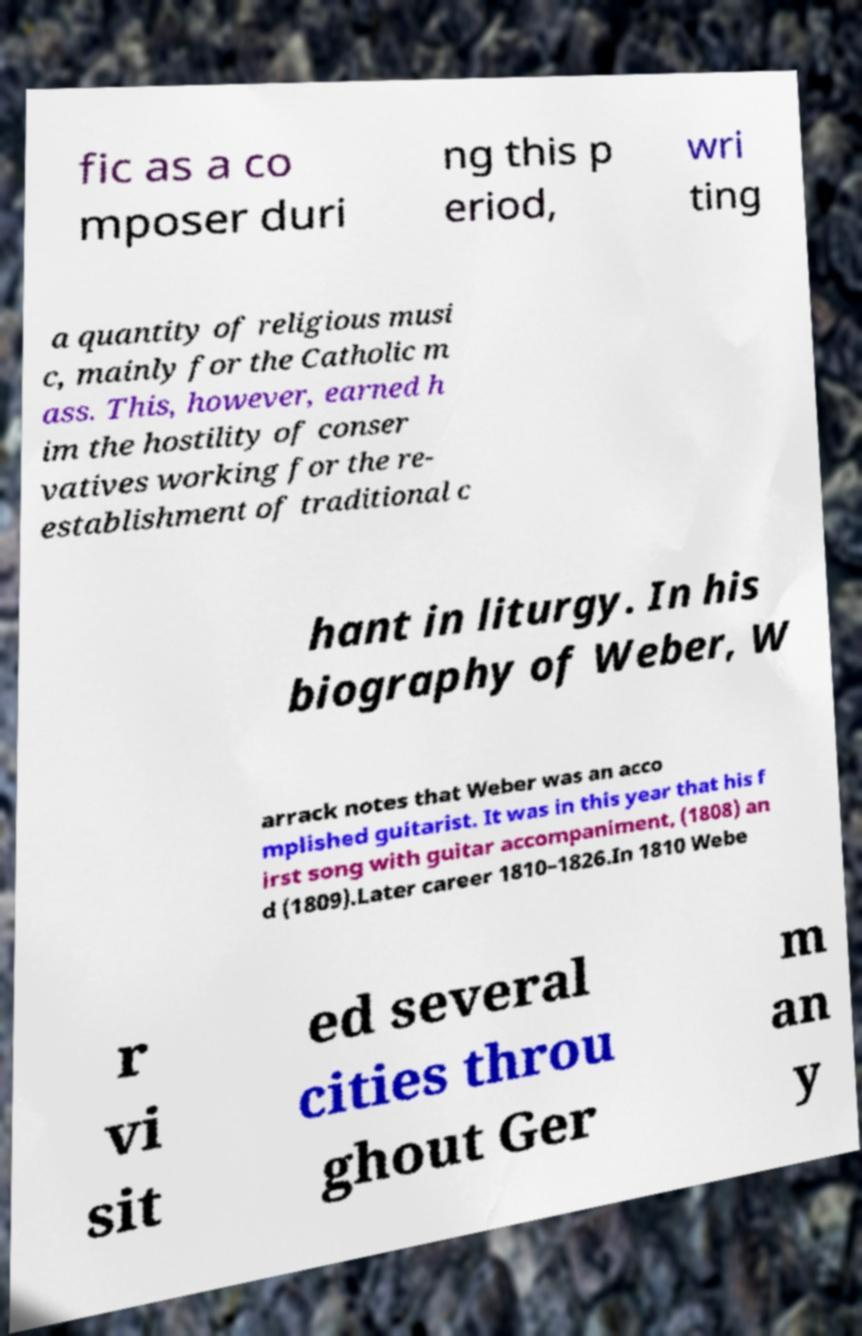Can you accurately transcribe the text from the provided image for me? fic as a co mposer duri ng this p eriod, wri ting a quantity of religious musi c, mainly for the Catholic m ass. This, however, earned h im the hostility of conser vatives working for the re- establishment of traditional c hant in liturgy. In his biography of Weber, W arrack notes that Weber was an acco mplished guitarist. It was in this year that his f irst song with guitar accompaniment, (1808) an d (1809).Later career 1810–1826.In 1810 Webe r vi sit ed several cities throu ghout Ger m an y 